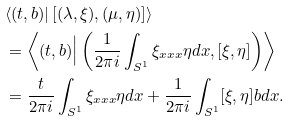<formula> <loc_0><loc_0><loc_500><loc_500>& \langle ( t , b ) | \left [ ( \lambda , \xi ) , ( \mu , \eta ) \right ] \rangle \\ & = \left \langle ( t , b ) \Big | \left ( \frac { 1 } { 2 \pi i } \int _ { S ^ { 1 } } \xi _ { x x x } \eta d x , [ \xi , \eta ] \right ) \right \rangle \\ & = \frac { t } { 2 \pi i } \int _ { S ^ { 1 } } \xi _ { x x x } \eta d x + \frac { 1 } { 2 \pi i } \int _ { S ^ { 1 } } [ \xi , \eta ] b d x .</formula> 